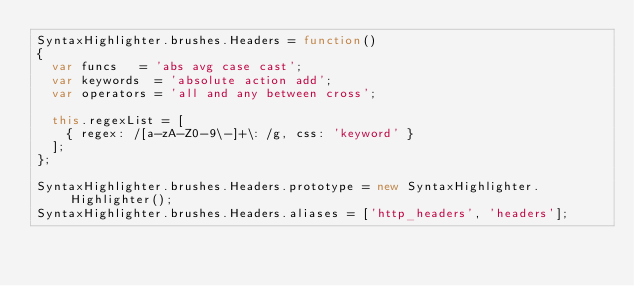Convert code to text. <code><loc_0><loc_0><loc_500><loc_500><_JavaScript_>SyntaxHighlighter.brushes.Headers = function()
{
	var funcs		= 'abs avg case cast';
	var keywords	= 'absolute action add';
	var operators	= 'all and any between cross';

	this.regexList = [
		{ regex: /[a-zA-Z0-9\-]+\: /g, css: 'keyword' }
	];
};

SyntaxHighlighter.brushes.Headers.prototype = new SyntaxHighlighter.Highlighter();
SyntaxHighlighter.brushes.Headers.aliases	= ['http_headers', 'headers'];
</code> 